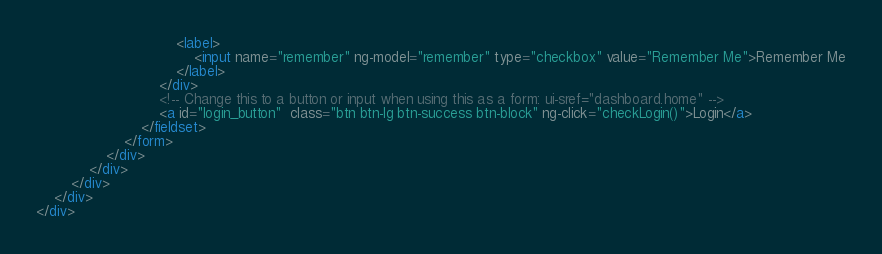<code> <loc_0><loc_0><loc_500><loc_500><_HTML_>                                <label>
                                    <input name="remember" ng-model="remember" type="checkbox" value="Remember Me">Remember Me
                                </label>
                            </div>
                            <!-- Change this to a button or input when using this as a form: ui-sref="dashboard.home" -->
                            <a id="login_button"  class="btn btn-lg btn-success btn-block" ng-click="checkLogin()">Login</a>
                        </fieldset>
                    </form>
                </div>
            </div>
        </div>
    </div>
</div></code> 